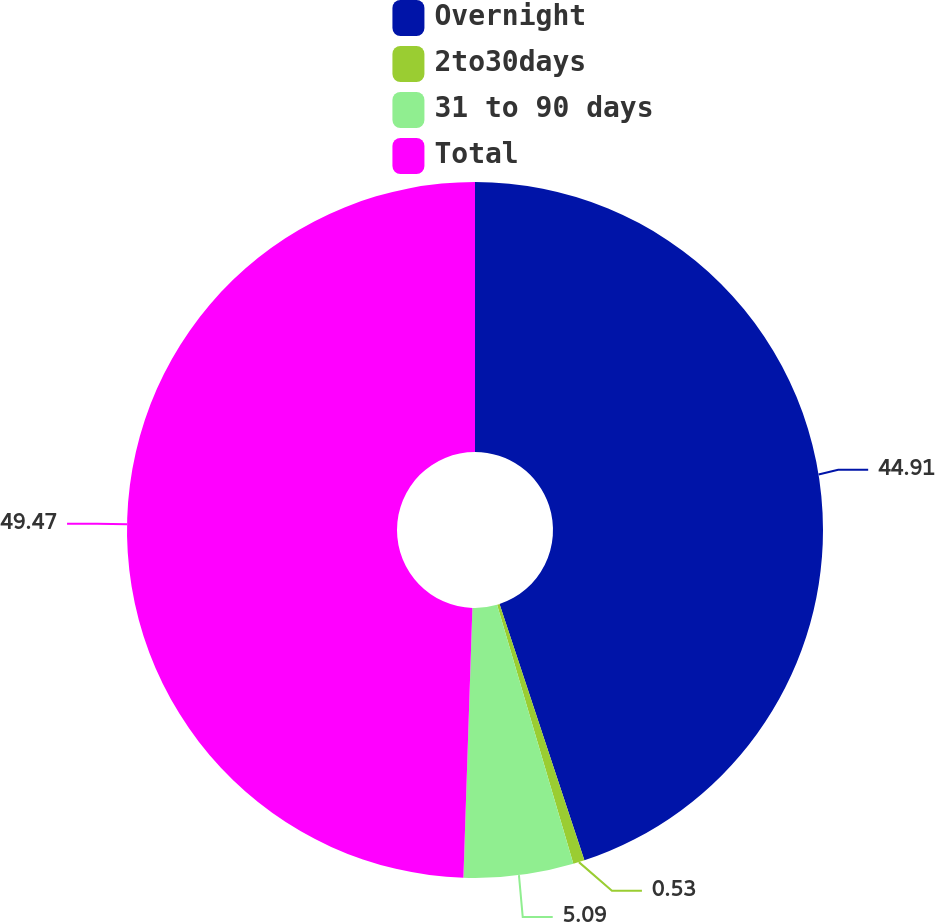<chart> <loc_0><loc_0><loc_500><loc_500><pie_chart><fcel>Overnight<fcel>2to30days<fcel>31 to 90 days<fcel>Total<nl><fcel>44.91%<fcel>0.53%<fcel>5.09%<fcel>49.47%<nl></chart> 